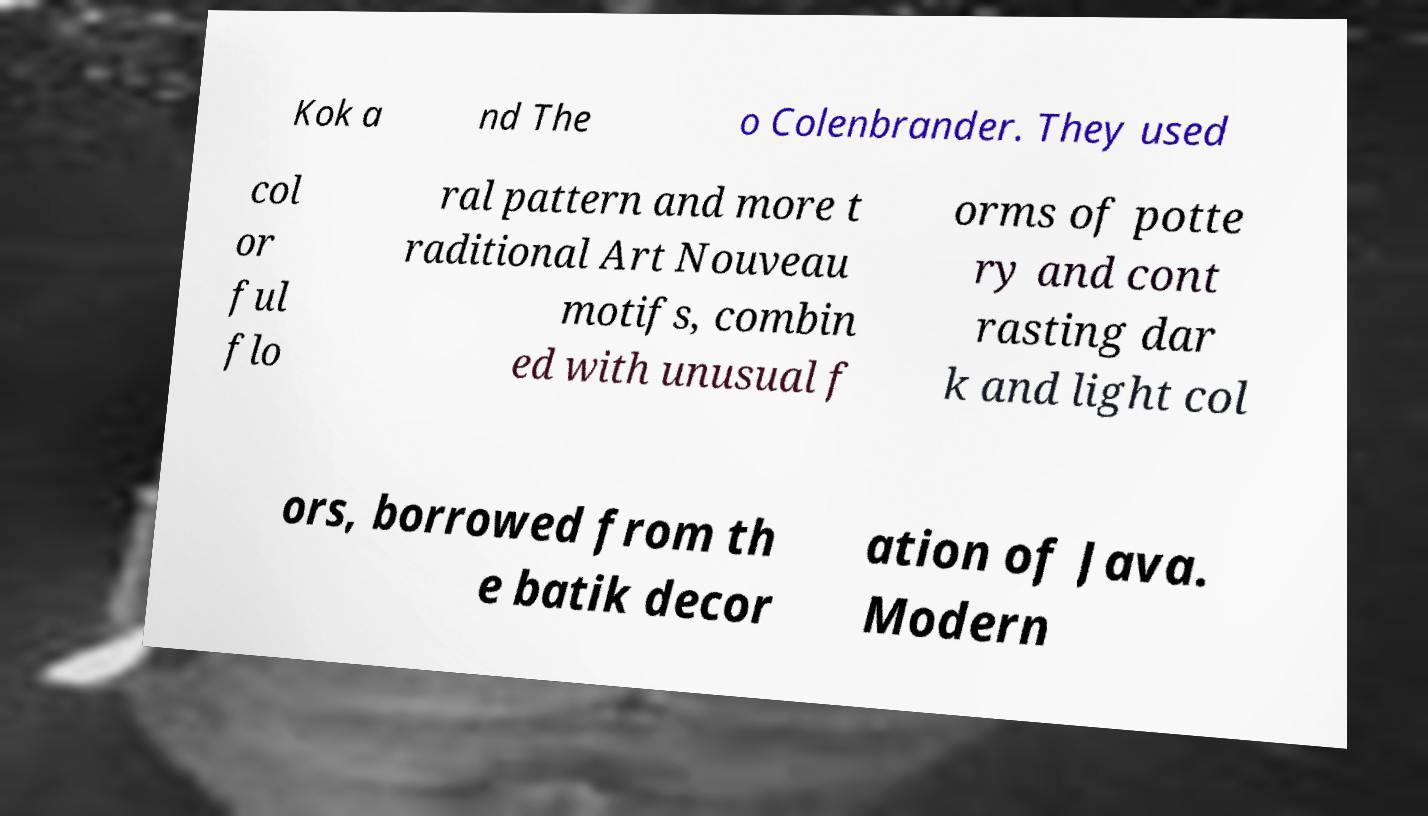For documentation purposes, I need the text within this image transcribed. Could you provide that? Kok a nd The o Colenbrander. They used col or ful flo ral pattern and more t raditional Art Nouveau motifs, combin ed with unusual f orms of potte ry and cont rasting dar k and light col ors, borrowed from th e batik decor ation of Java. Modern 